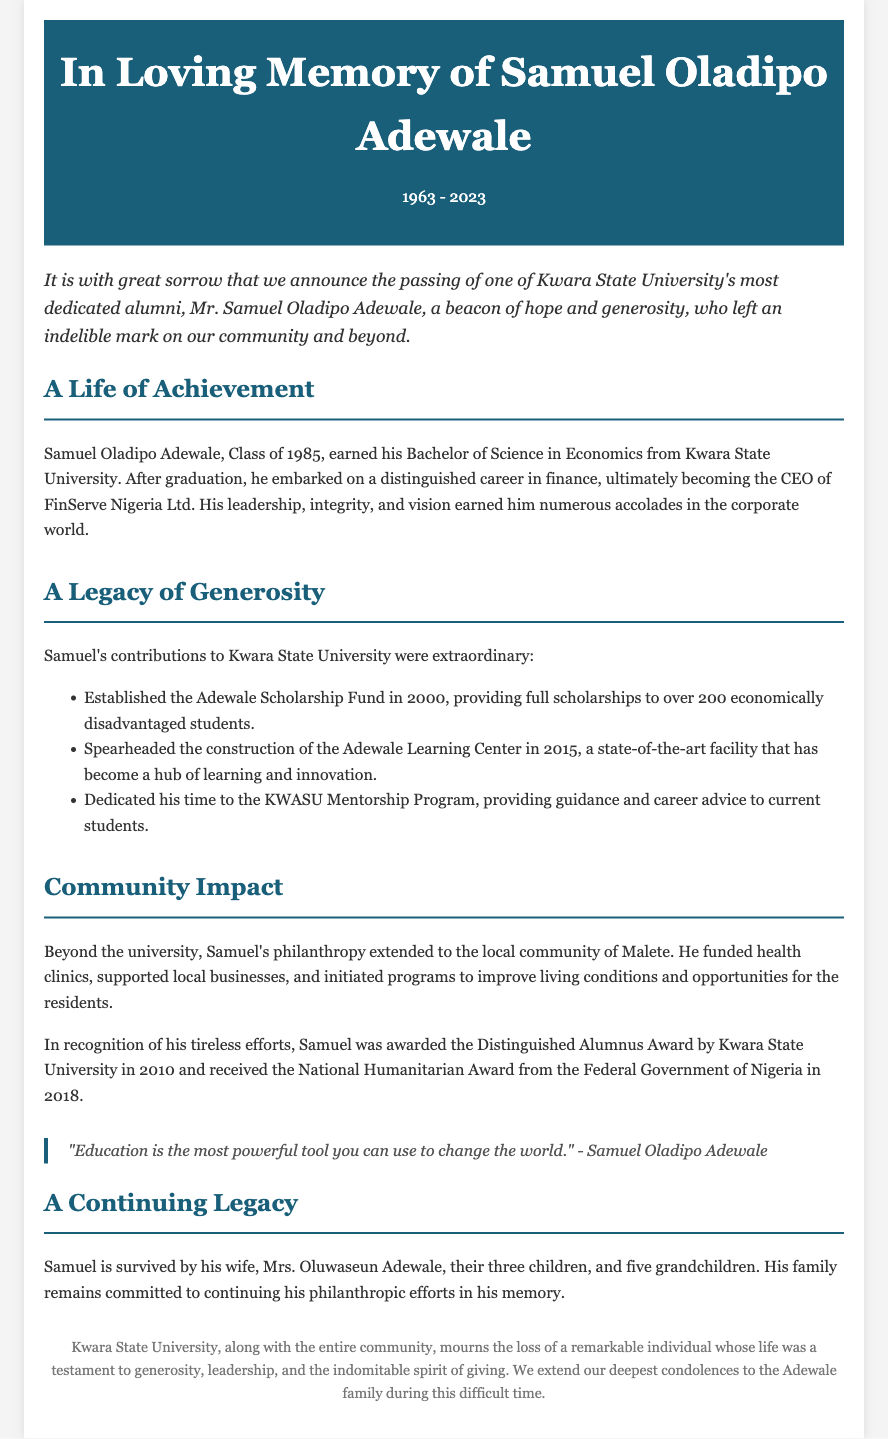What year was Samuel Oladipo Adewale born? The document states that Samuel was born in 1963.
Answer: 1963 What degree did Samuel earn from Kwara State University? The document mentions that Samuel earned a Bachelor of Science in Economics.
Answer: Bachelor of Science in Economics How many scholarships did the Adewale Scholarship Fund provide? The document indicates that the fund provided full scholarships to over 200 students.
Answer: over 200 In what year was the Adewale Learning Center constructed? According to the document, the center was constructed in 2015.
Answer: 2015 What award did Samuel receive in 2010? The document states that he received the Distinguished Alumnus Award.
Answer: Distinguished Alumnus Award What did Samuel believe was the most powerful tool to change the world? Samuel's quote in the document emphasizes that education is the most powerful tool.
Answer: Education What is the name of Samuel's wife? The document mentions that Samuel is survived by his wife, Mrs. Oluwaseun Adewale.
Answer: Mrs. Oluwaseun Adewale What community initiatives did Samuel support? The document outlines that he funded health clinics and supported local businesses.
Answer: health clinics and local businesses What was the date range of Samuel's life? The document specifies that he lived from 1963 to 2023.
Answer: 1963 - 2023 